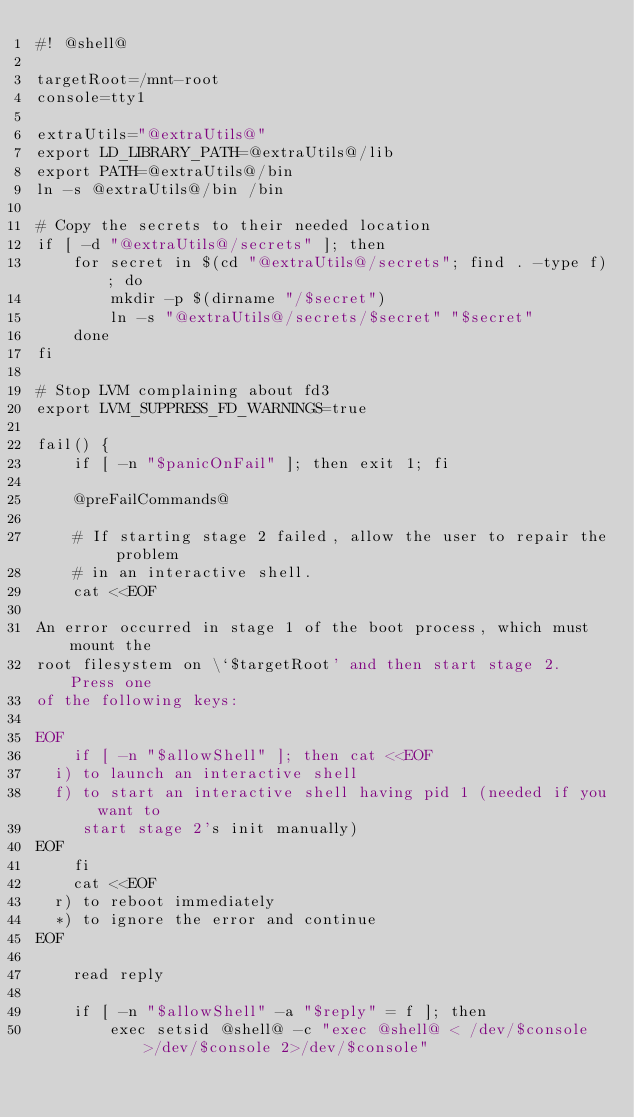<code> <loc_0><loc_0><loc_500><loc_500><_Bash_>#! @shell@

targetRoot=/mnt-root
console=tty1

extraUtils="@extraUtils@"
export LD_LIBRARY_PATH=@extraUtils@/lib
export PATH=@extraUtils@/bin
ln -s @extraUtils@/bin /bin

# Copy the secrets to their needed location
if [ -d "@extraUtils@/secrets" ]; then
    for secret in $(cd "@extraUtils@/secrets"; find . -type f); do
        mkdir -p $(dirname "/$secret")
        ln -s "@extraUtils@/secrets/$secret" "$secret"
    done
fi

# Stop LVM complaining about fd3
export LVM_SUPPRESS_FD_WARNINGS=true

fail() {
    if [ -n "$panicOnFail" ]; then exit 1; fi

    @preFailCommands@

    # If starting stage 2 failed, allow the user to repair the problem
    # in an interactive shell.
    cat <<EOF

An error occurred in stage 1 of the boot process, which must mount the
root filesystem on \`$targetRoot' and then start stage 2.  Press one
of the following keys:

EOF
    if [ -n "$allowShell" ]; then cat <<EOF
  i) to launch an interactive shell
  f) to start an interactive shell having pid 1 (needed if you want to
     start stage 2's init manually)
EOF
    fi
    cat <<EOF
  r) to reboot immediately
  *) to ignore the error and continue
EOF

    read reply

    if [ -n "$allowShell" -a "$reply" = f ]; then
        exec setsid @shell@ -c "exec @shell@ < /dev/$console >/dev/$console 2>/dev/$console"</code> 